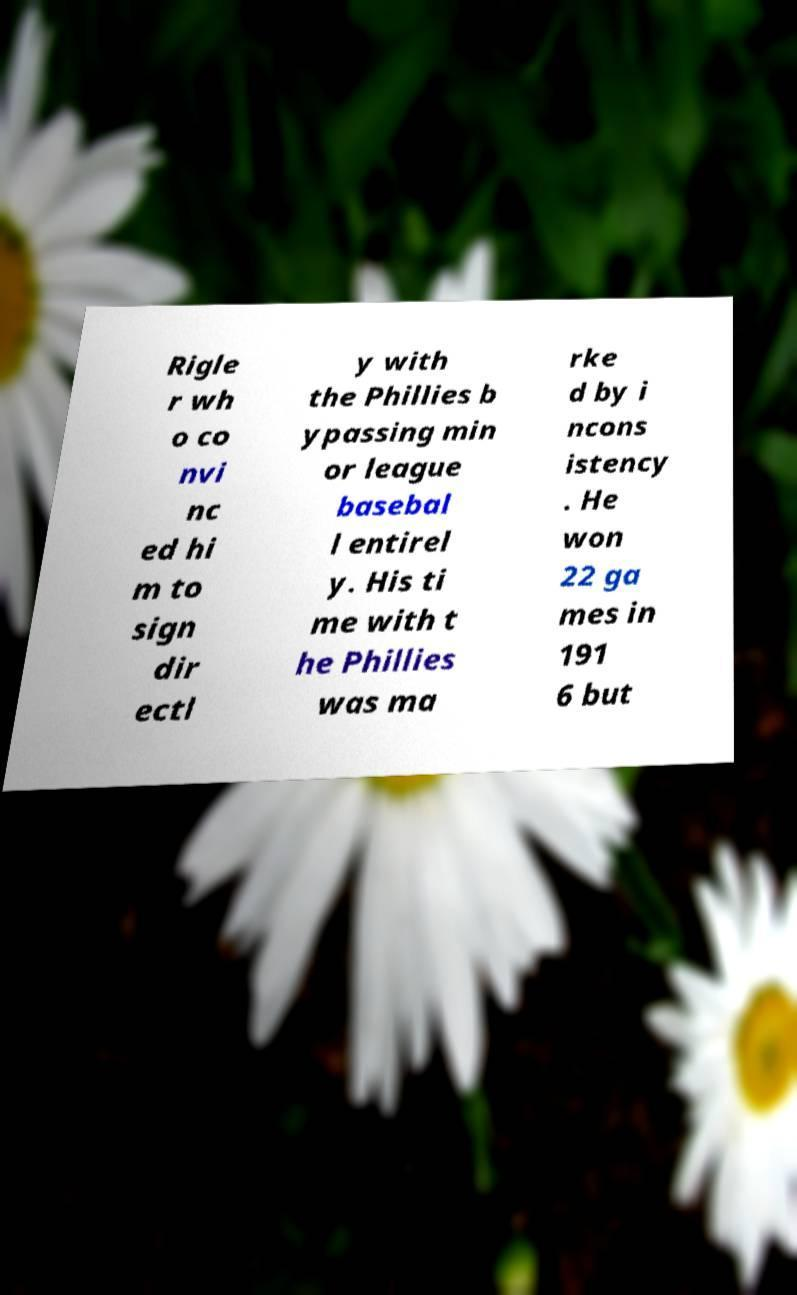Can you read and provide the text displayed in the image?This photo seems to have some interesting text. Can you extract and type it out for me? Rigle r wh o co nvi nc ed hi m to sign dir ectl y with the Phillies b ypassing min or league basebal l entirel y. His ti me with t he Phillies was ma rke d by i ncons istency . He won 22 ga mes in 191 6 but 